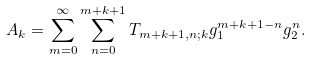Convert formula to latex. <formula><loc_0><loc_0><loc_500><loc_500>A _ { k } = \sum _ { m = 0 } ^ { \infty } \sum _ { n = 0 } ^ { m + k + 1 } T _ { m + k + 1 , n ; k } g _ { 1 } ^ { m + k + 1 - n } g _ { 2 } ^ { n } .</formula> 